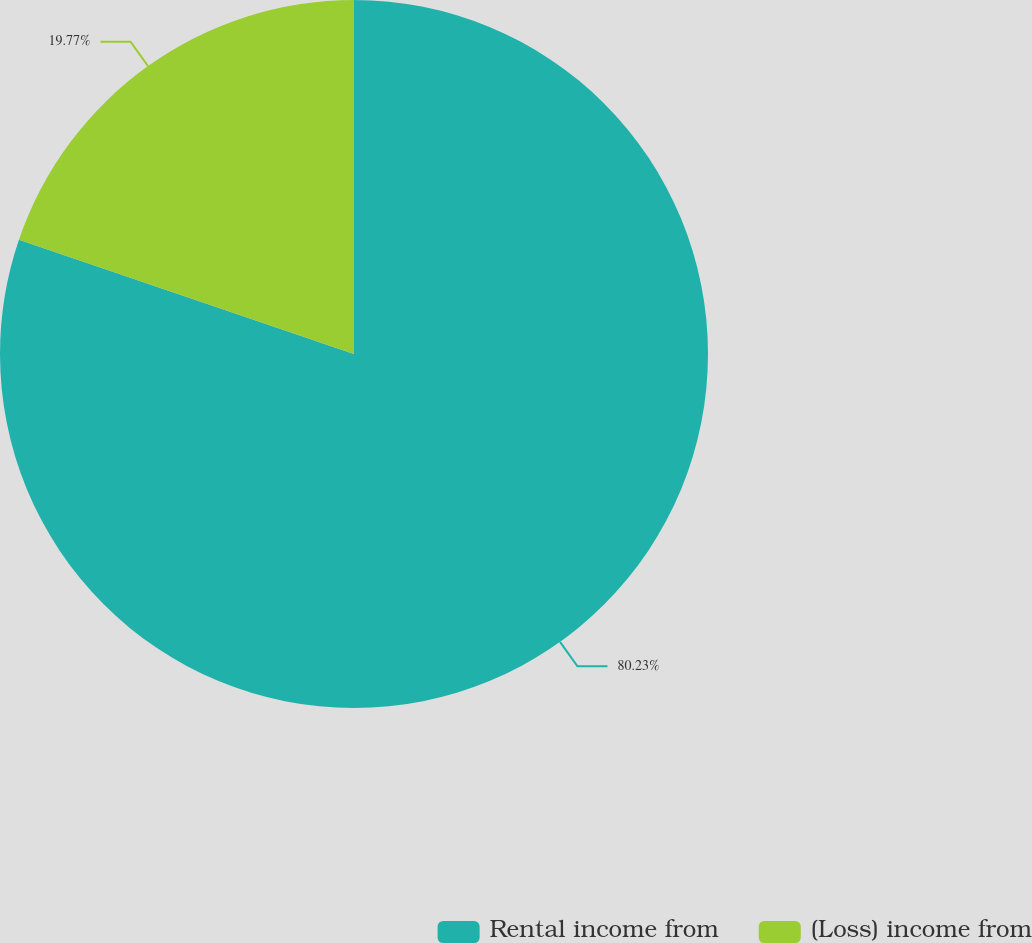Convert chart to OTSL. <chart><loc_0><loc_0><loc_500><loc_500><pie_chart><fcel>Rental income from<fcel>(Loss) income from<nl><fcel>80.23%<fcel>19.77%<nl></chart> 